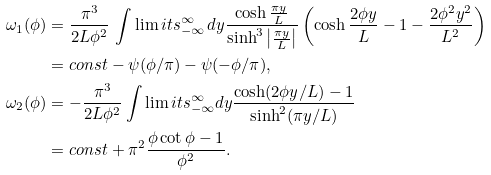Convert formula to latex. <formula><loc_0><loc_0><loc_500><loc_500>\omega _ { 1 } ( \phi ) & = \frac { \pi ^ { 3 } } { 2 L \phi ^ { 2 } } \, \int \lim i t s _ { - \infty } ^ { \infty } \, d y \frac { \cosh \frac { \pi y } { L } } { \sinh ^ { 3 } \left | \frac { \pi y } { L } \right | } \left ( \cosh \frac { 2 \phi y } { L } - 1 - \frac { 2 \phi ^ { 2 } y ^ { 2 } } { L ^ { 2 } } \right ) \\ & = c o n s t - \psi ( \phi / \pi ) - \psi ( - \phi / \pi ) , \\ \omega _ { 2 } ( \phi ) & = - \frac { \pi ^ { 3 } } { 2 L \phi ^ { 2 } } \int \lim i t s _ { - \infty } ^ { \infty } d y \frac { \cosh ( 2 \phi y / L ) - 1 } { \sinh ^ { 2 } ( \pi y / L ) } \\ & = c o n s t + \pi ^ { 2 } \frac { \phi \cot \phi - 1 } { \phi ^ { 2 } } .</formula> 